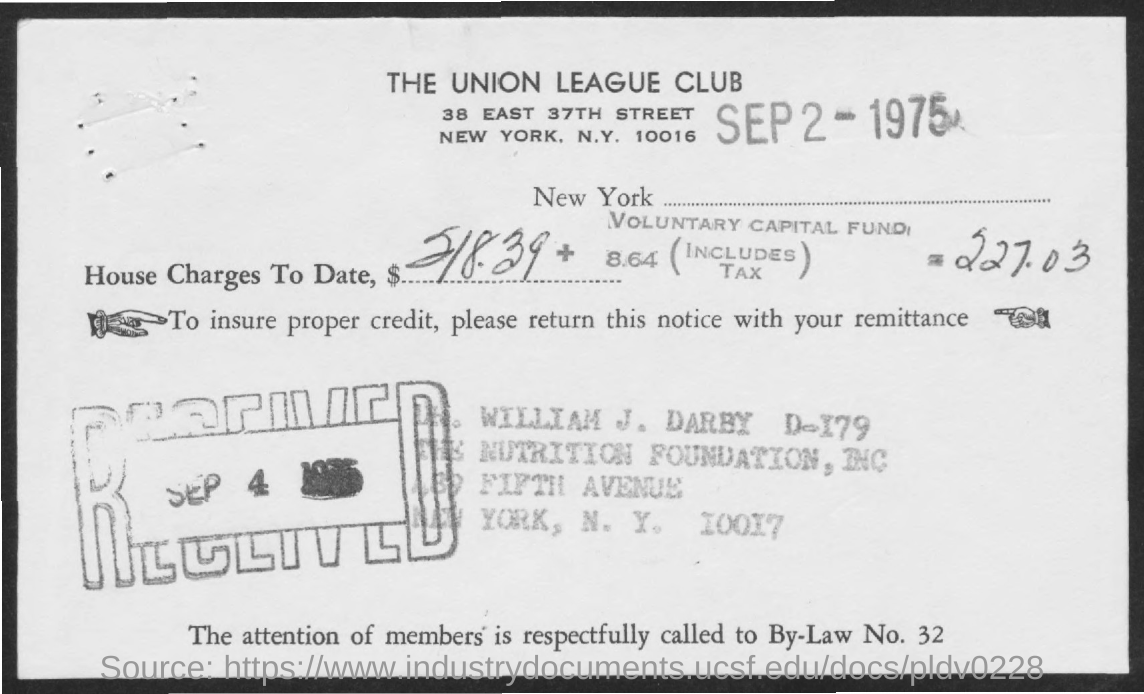What is the date on the document?
Provide a short and direct response. SEP 2 - 1975. What is the Tax?
Offer a terse response. 8.64. When is the Date Received?
Keep it short and to the point. SEP 4. 